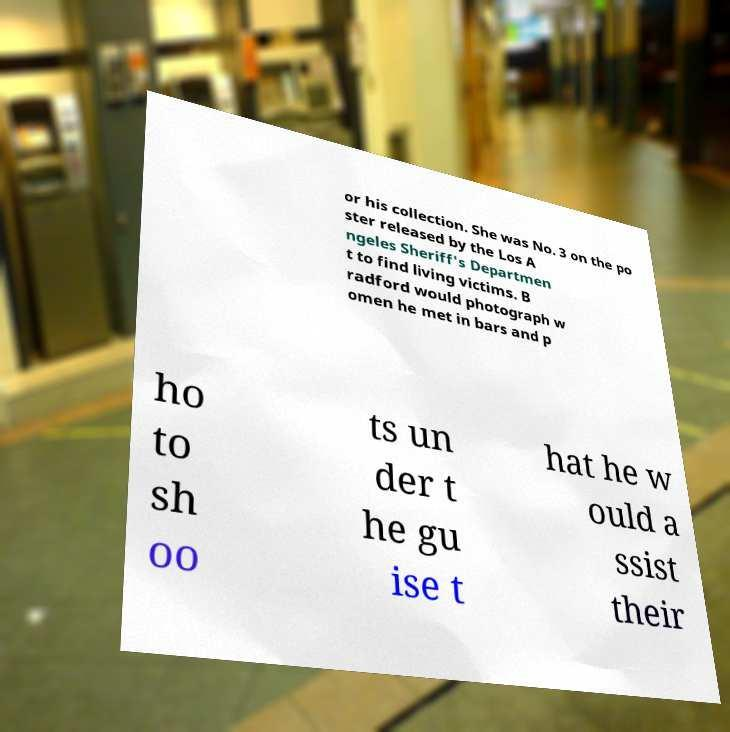For documentation purposes, I need the text within this image transcribed. Could you provide that? or his collection. She was No. 3 on the po ster released by the Los A ngeles Sheriff's Departmen t to find living victims. B radford would photograph w omen he met in bars and p ho to sh oo ts un der t he gu ise t hat he w ould a ssist their 